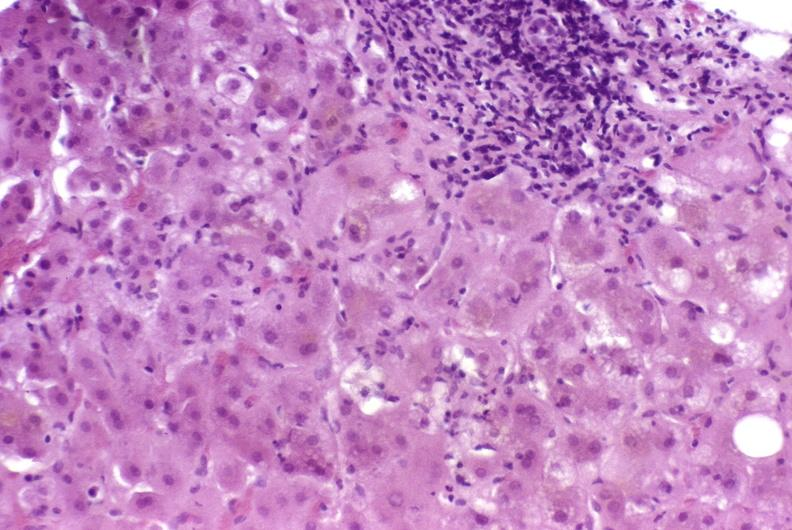s pinworm present?
Answer the question using a single word or phrase. No 